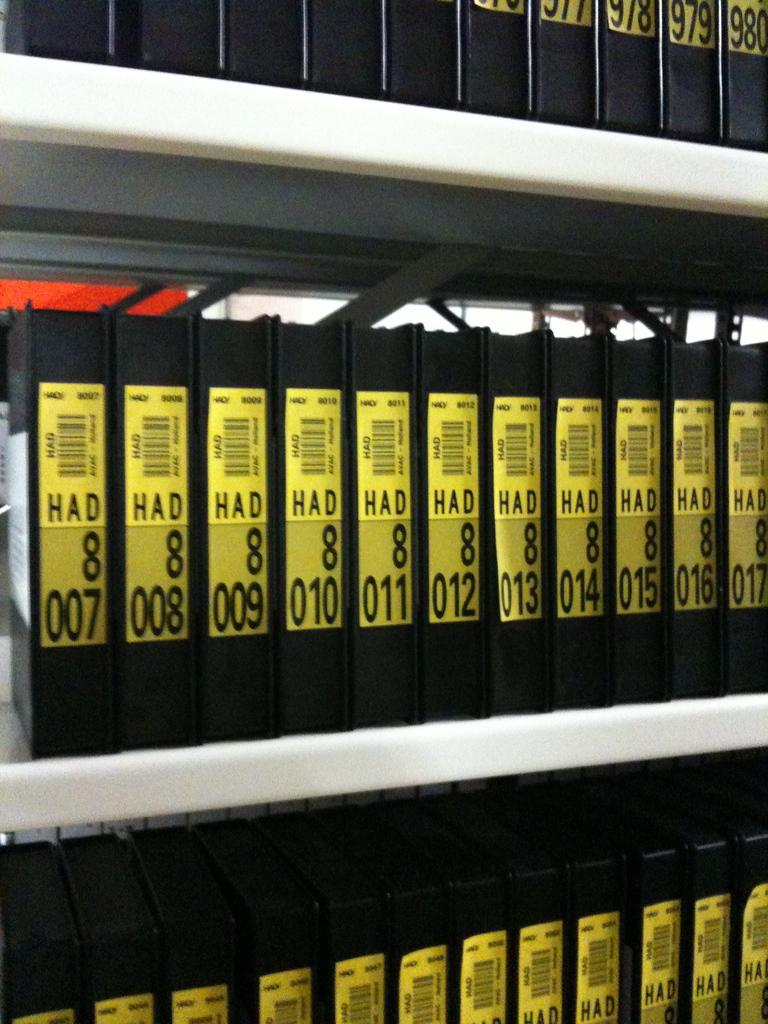<image>
Offer a succinct explanation of the picture presented. A lot of black boxes with a yellow label and all of them have the word HAD on them. 